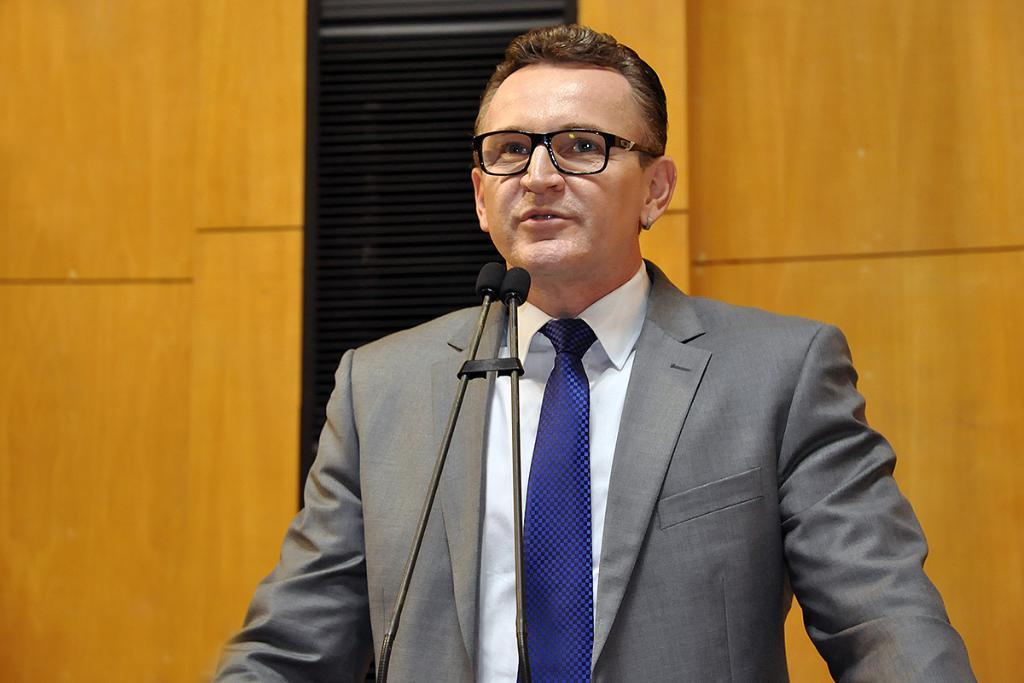What is the person in the image doing? The person is standing and talking in the image. What objects are present that might be related to the person's activity? There are microphones in the image. What can be seen in the background of the image? There is a wall and a speaker in the background of the image. Can you see a flock of birds flying in the image? No, there is no flock of birds visible in the image. What type of waves can be seen crashing on the shore in the image? There is no shore or waves present in the image. 